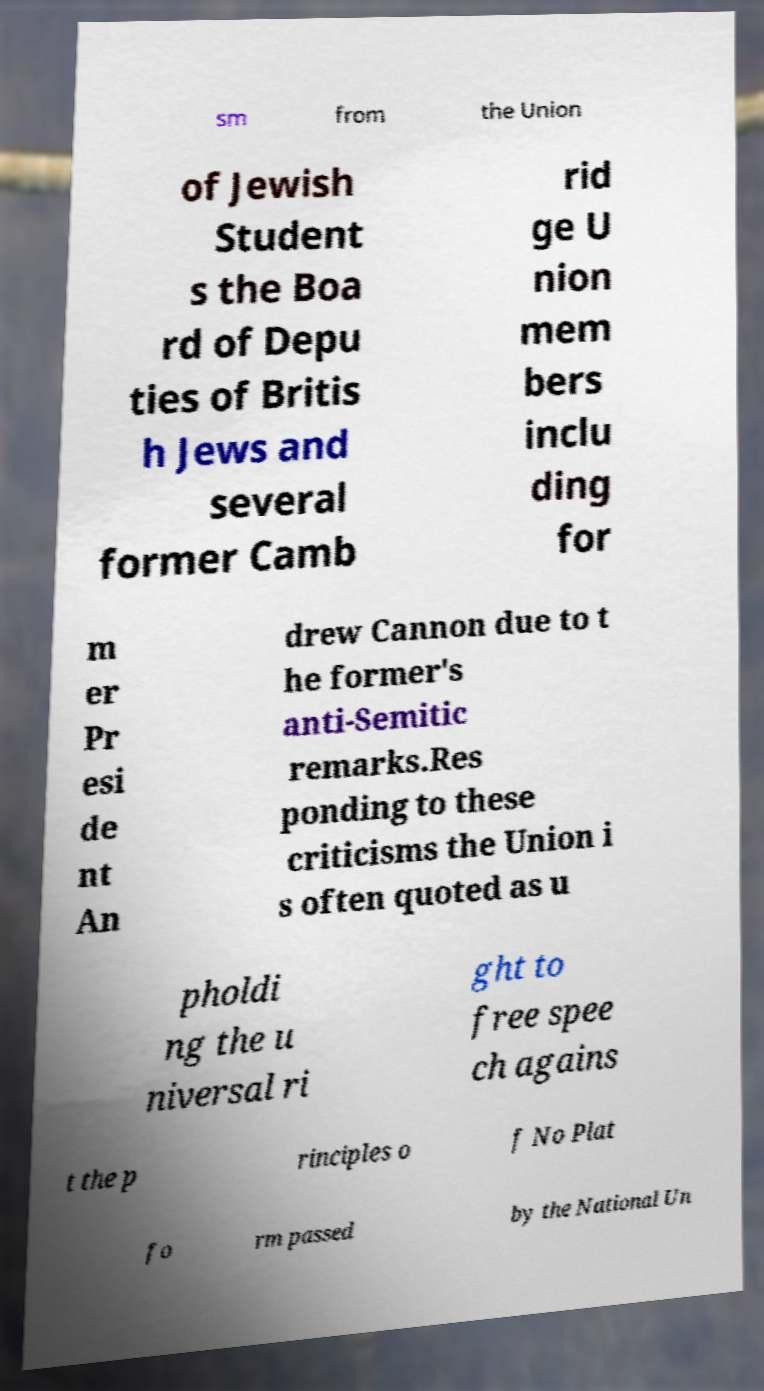There's text embedded in this image that I need extracted. Can you transcribe it verbatim? sm from the Union of Jewish Student s the Boa rd of Depu ties of Britis h Jews and several former Camb rid ge U nion mem bers inclu ding for m er Pr esi de nt An drew Cannon due to t he former's anti-Semitic remarks.Res ponding to these criticisms the Union i s often quoted as u pholdi ng the u niversal ri ght to free spee ch agains t the p rinciples o f No Plat fo rm passed by the National Un 